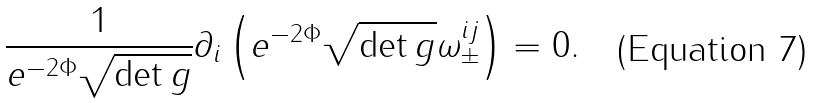<formula> <loc_0><loc_0><loc_500><loc_500>\frac { 1 } { e ^ { - 2 \Phi } \sqrt { \det g } } \partial _ { i } \left ( e ^ { - 2 \Phi } \sqrt { \det g } \omega _ { \pm } ^ { i j } \right ) = 0 .</formula> 